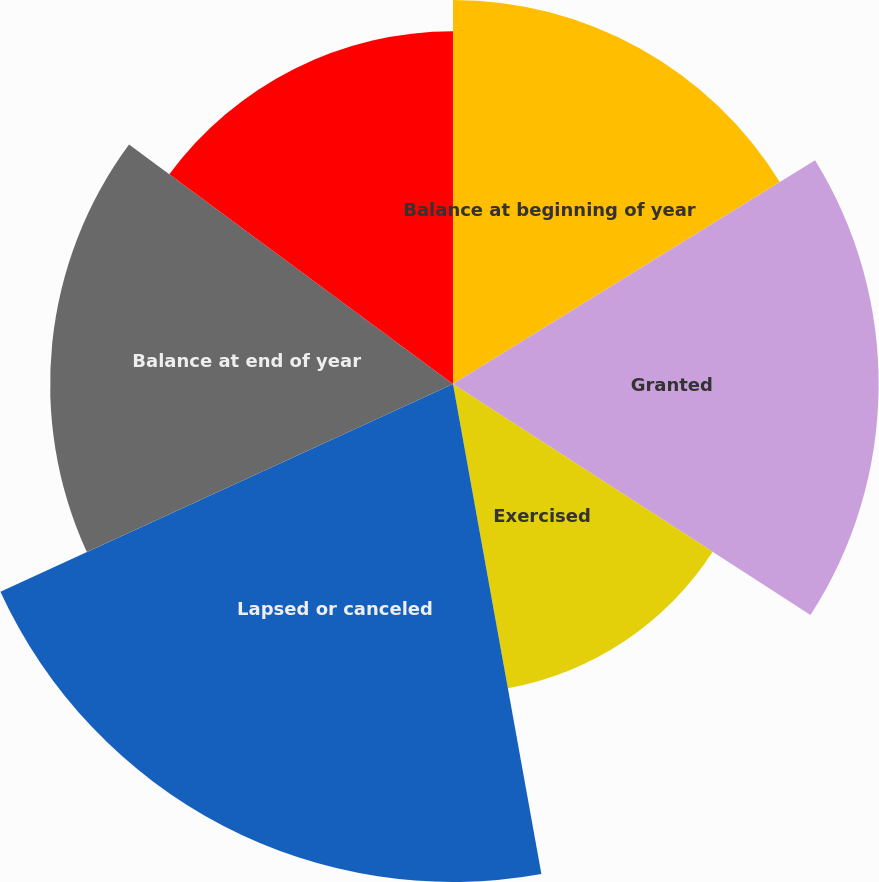Convert chart to OTSL. <chart><loc_0><loc_0><loc_500><loc_500><pie_chart><fcel>Balance at beginning of year<fcel>Granted<fcel>Exercised<fcel>Lapsed or canceled<fcel>Balance at end of year<fcel>Options exercisable at end of<nl><fcel>16.19%<fcel>17.94%<fcel>13.03%<fcel>20.99%<fcel>16.98%<fcel>14.87%<nl></chart> 